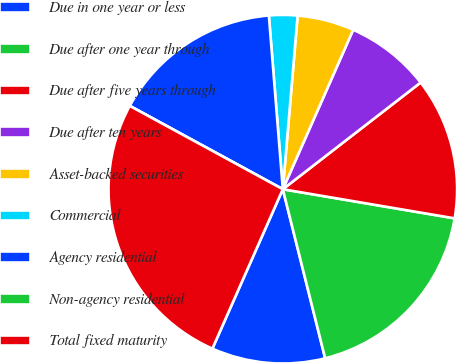Convert chart. <chart><loc_0><loc_0><loc_500><loc_500><pie_chart><fcel>Due in one year or less<fcel>Due after one year through<fcel>Due after five years through<fcel>Due after ten years<fcel>Asset-backed securities<fcel>Commercial<fcel>Agency residential<fcel>Non-agency residential<fcel>Total fixed maturity<nl><fcel>10.53%<fcel>18.42%<fcel>13.16%<fcel>7.9%<fcel>5.26%<fcel>2.63%<fcel>15.79%<fcel>0.0%<fcel>26.31%<nl></chart> 